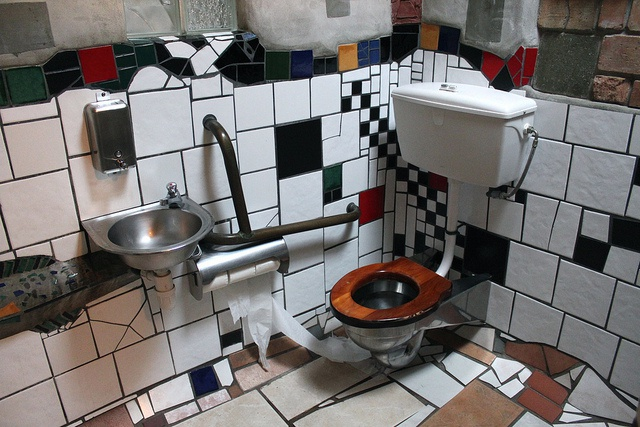Describe the objects in this image and their specific colors. I can see toilet in gray, black, maroon, and white tones and sink in gray, black, darkgray, and lightgray tones in this image. 